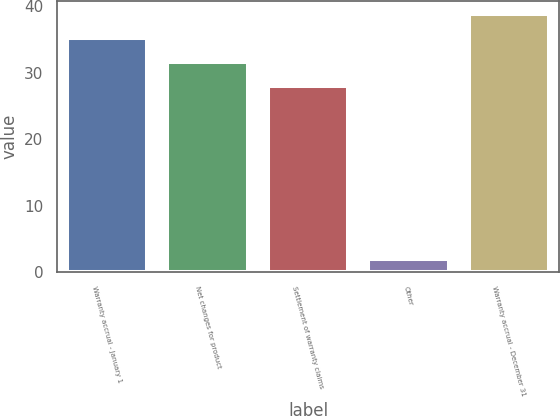<chart> <loc_0><loc_0><loc_500><loc_500><bar_chart><fcel>Warranty accrual - January 1<fcel>Net changes for product<fcel>Settlement of warranty claims<fcel>Other<fcel>Warranty accrual - December 31<nl><fcel>35.2<fcel>31.6<fcel>28<fcel>2<fcel>38.8<nl></chart> 